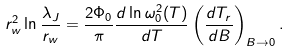Convert formula to latex. <formula><loc_0><loc_0><loc_500><loc_500>r _ { w } ^ { 2 } \ln \frac { \lambda _ { J } } { r _ { w } } = \frac { 2 \Phi _ { 0 } } { \pi } \frac { d \ln \omega _ { 0 } ^ { 2 } ( T ) } { d T } \left ( \frac { d T _ { r } } { d B } \right ) _ { B \rightarrow 0 } .</formula> 